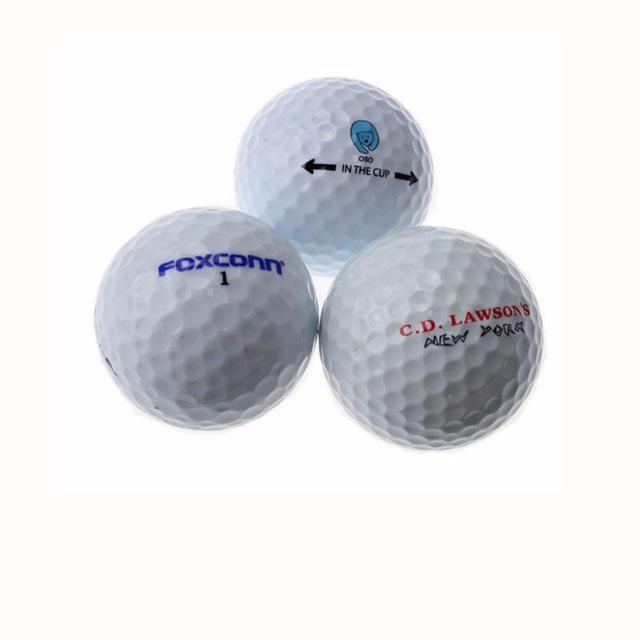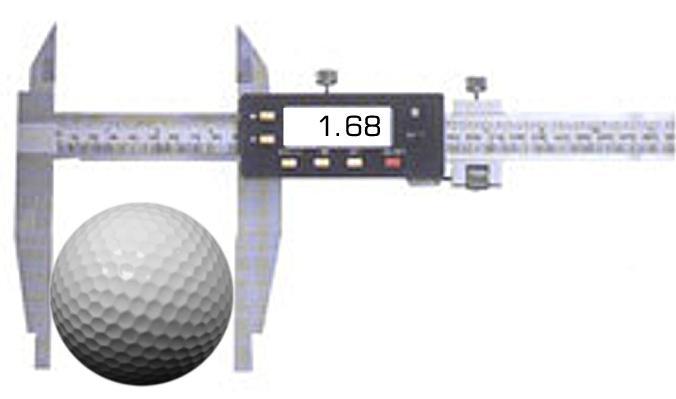The first image is the image on the left, the second image is the image on the right. Given the left and right images, does the statement "The right image contains exactly three golf balls in a triangular formation." hold true? Answer yes or no. No. The first image is the image on the left, the second image is the image on the right. Assess this claim about the two images: "One image shows a pyramid shape formed by three golf balls, and the other image contains no more than one golf ball.". Correct or not? Answer yes or no. Yes. 